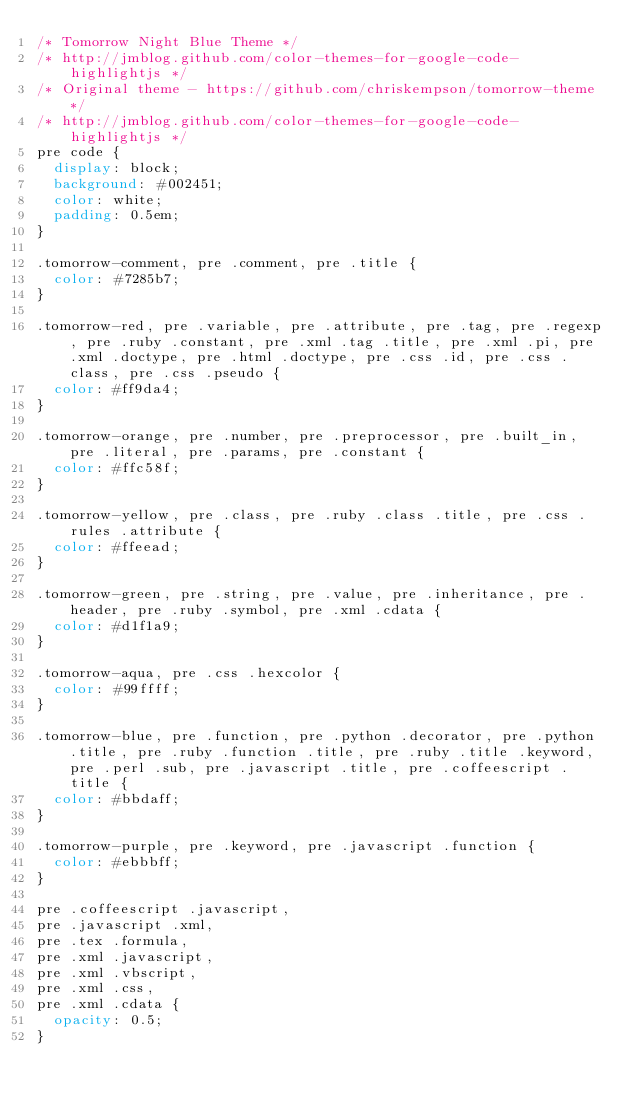<code> <loc_0><loc_0><loc_500><loc_500><_CSS_>/* Tomorrow Night Blue Theme */
/* http://jmblog.github.com/color-themes-for-google-code-highlightjs */
/* Original theme - https://github.com/chriskempson/tomorrow-theme */
/* http://jmblog.github.com/color-themes-for-google-code-highlightjs */
pre code {
  display: block;
  background: #002451;
  color: white;
  padding: 0.5em;
}

.tomorrow-comment, pre .comment, pre .title {
  color: #7285b7;
}

.tomorrow-red, pre .variable, pre .attribute, pre .tag, pre .regexp, pre .ruby .constant, pre .xml .tag .title, pre .xml .pi, pre .xml .doctype, pre .html .doctype, pre .css .id, pre .css .class, pre .css .pseudo {
  color: #ff9da4;
}

.tomorrow-orange, pre .number, pre .preprocessor, pre .built_in, pre .literal, pre .params, pre .constant {
  color: #ffc58f;
}

.tomorrow-yellow, pre .class, pre .ruby .class .title, pre .css .rules .attribute {
  color: #ffeead;
}

.tomorrow-green, pre .string, pre .value, pre .inheritance, pre .header, pre .ruby .symbol, pre .xml .cdata {
  color: #d1f1a9;
}

.tomorrow-aqua, pre .css .hexcolor {
  color: #99ffff;
}

.tomorrow-blue, pre .function, pre .python .decorator, pre .python .title, pre .ruby .function .title, pre .ruby .title .keyword, pre .perl .sub, pre .javascript .title, pre .coffeescript .title {
  color: #bbdaff;
}

.tomorrow-purple, pre .keyword, pre .javascript .function {
  color: #ebbbff;
}

pre .coffeescript .javascript,
pre .javascript .xml,
pre .tex .formula,
pre .xml .javascript,
pre .xml .vbscript,
pre .xml .css,
pre .xml .cdata {
  opacity: 0.5;
}
</code> 